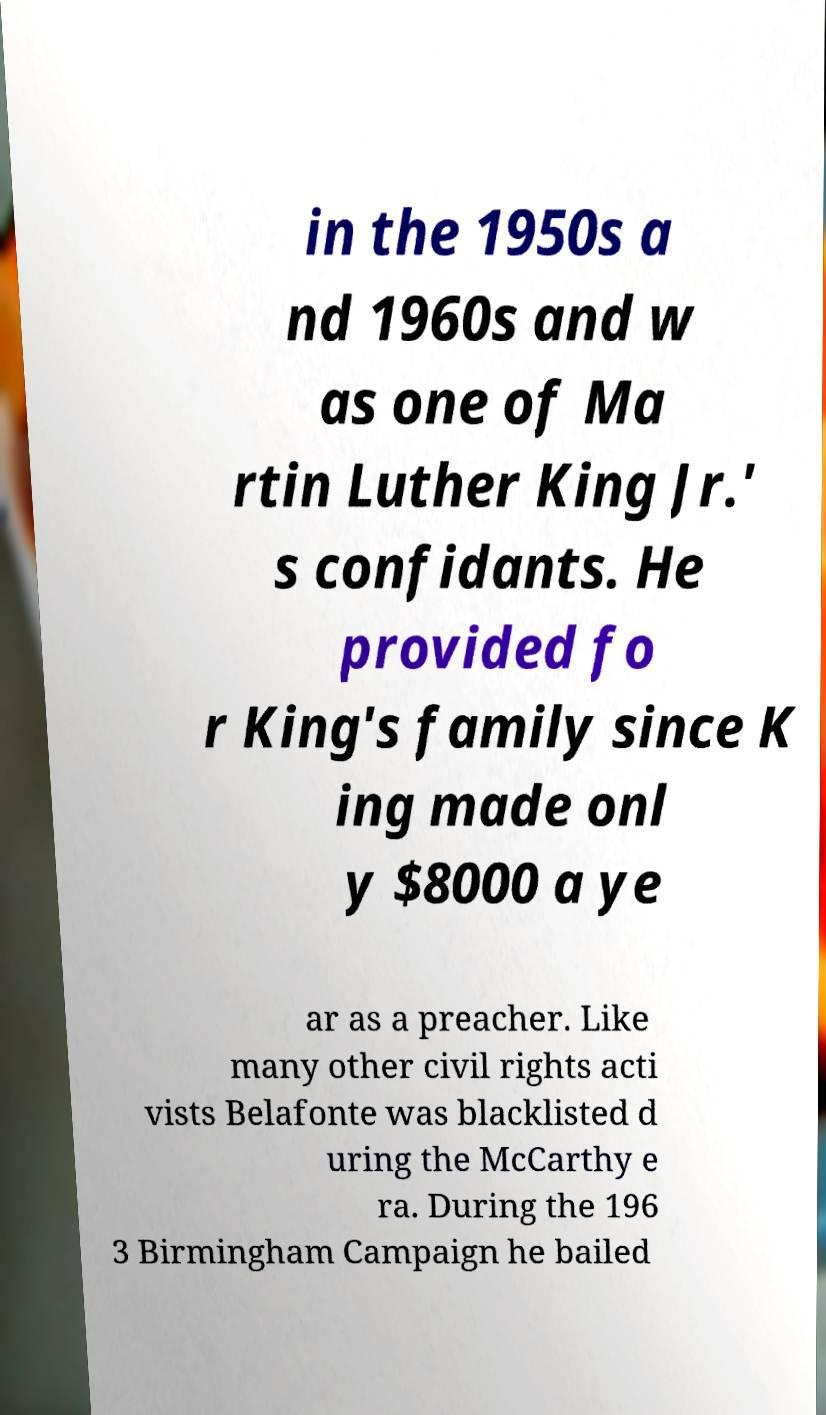Please identify and transcribe the text found in this image. in the 1950s a nd 1960s and w as one of Ma rtin Luther King Jr.' s confidants. He provided fo r King's family since K ing made onl y $8000 a ye ar as a preacher. Like many other civil rights acti vists Belafonte was blacklisted d uring the McCarthy e ra. During the 196 3 Birmingham Campaign he bailed 